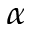Convert formula to latex. <formula><loc_0><loc_0><loc_500><loc_500>_ { \alpha }</formula> 